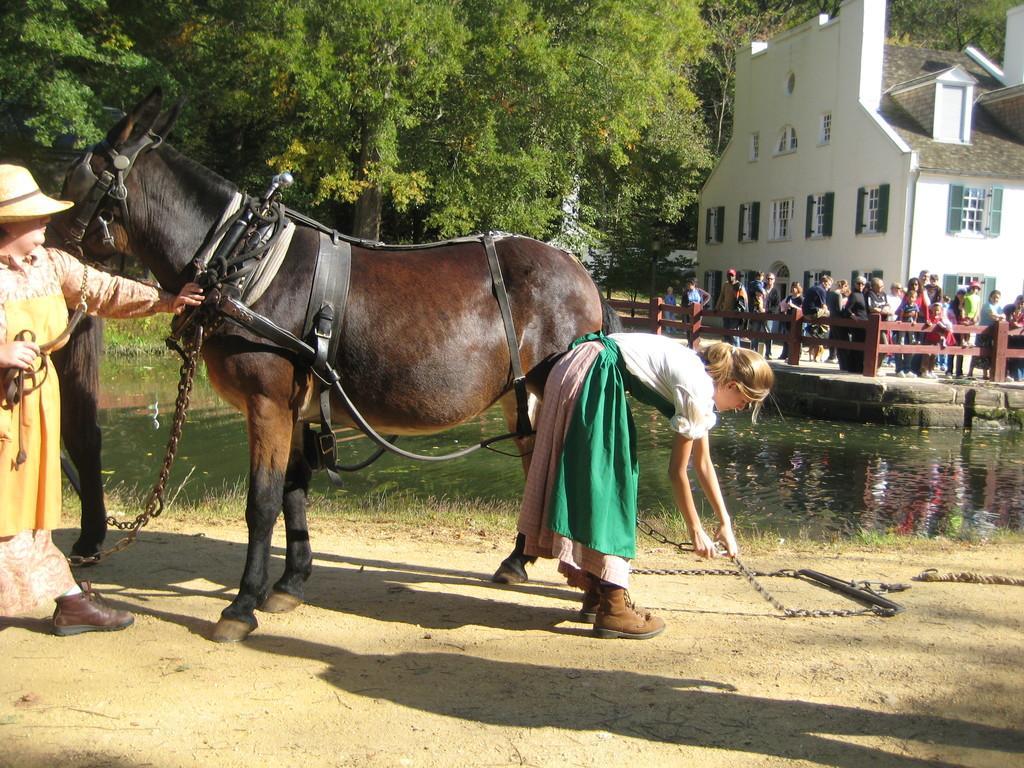How would you summarize this image in a sentence or two? This is the picture of a place where we have a person who is bending and holding the chain and behind her there is an other person who is holding the horse and to the side there is a lake, fencing and some people, building and some trees to the other side of the fencing. 